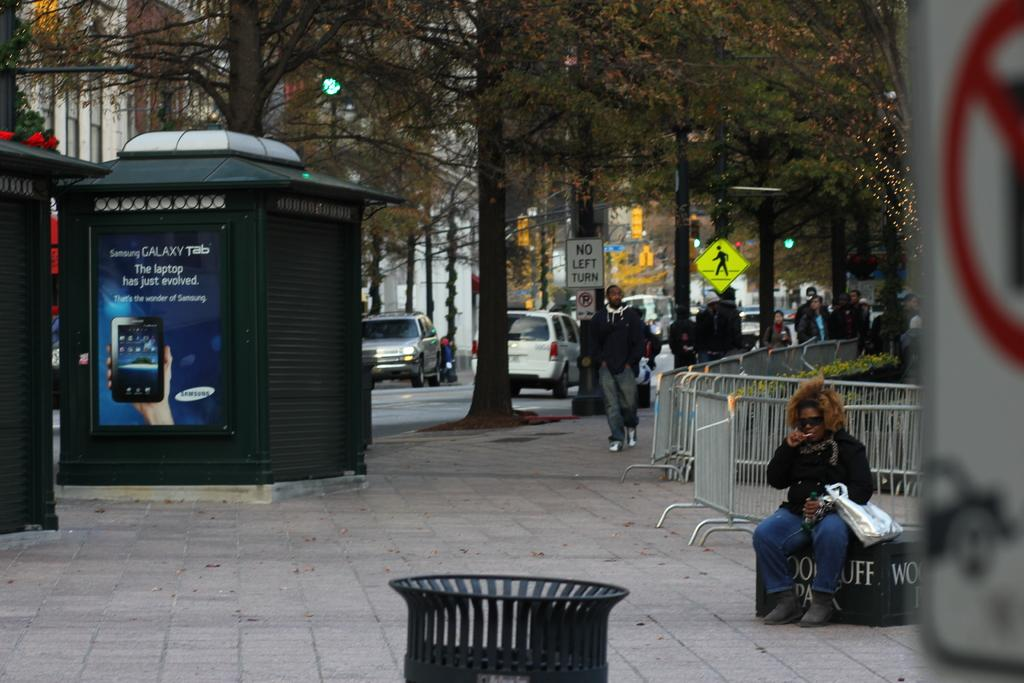<image>
Present a compact description of the photo's key features. A bust stop on a street has a poster on the side, advertising the Galaxy Tab. 